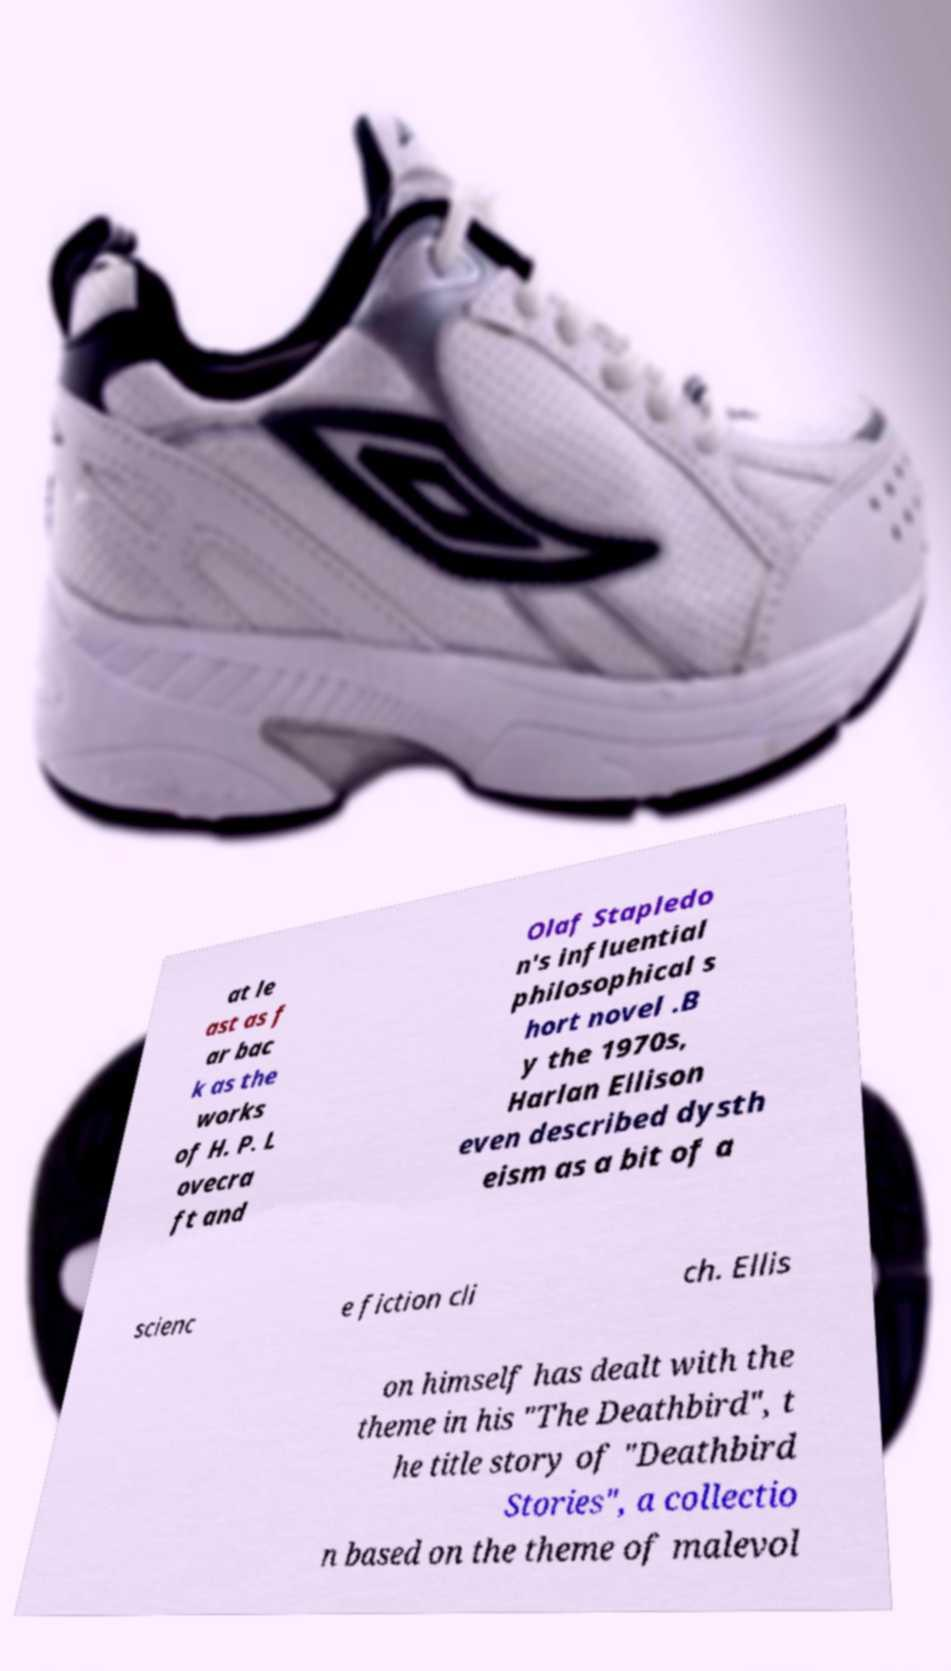Can you accurately transcribe the text from the provided image for me? at le ast as f ar bac k as the works of H. P. L ovecra ft and Olaf Stapledo n's influential philosophical s hort novel .B y the 1970s, Harlan Ellison even described dysth eism as a bit of a scienc e fiction cli ch. Ellis on himself has dealt with the theme in his "The Deathbird", t he title story of "Deathbird Stories", a collectio n based on the theme of malevol 